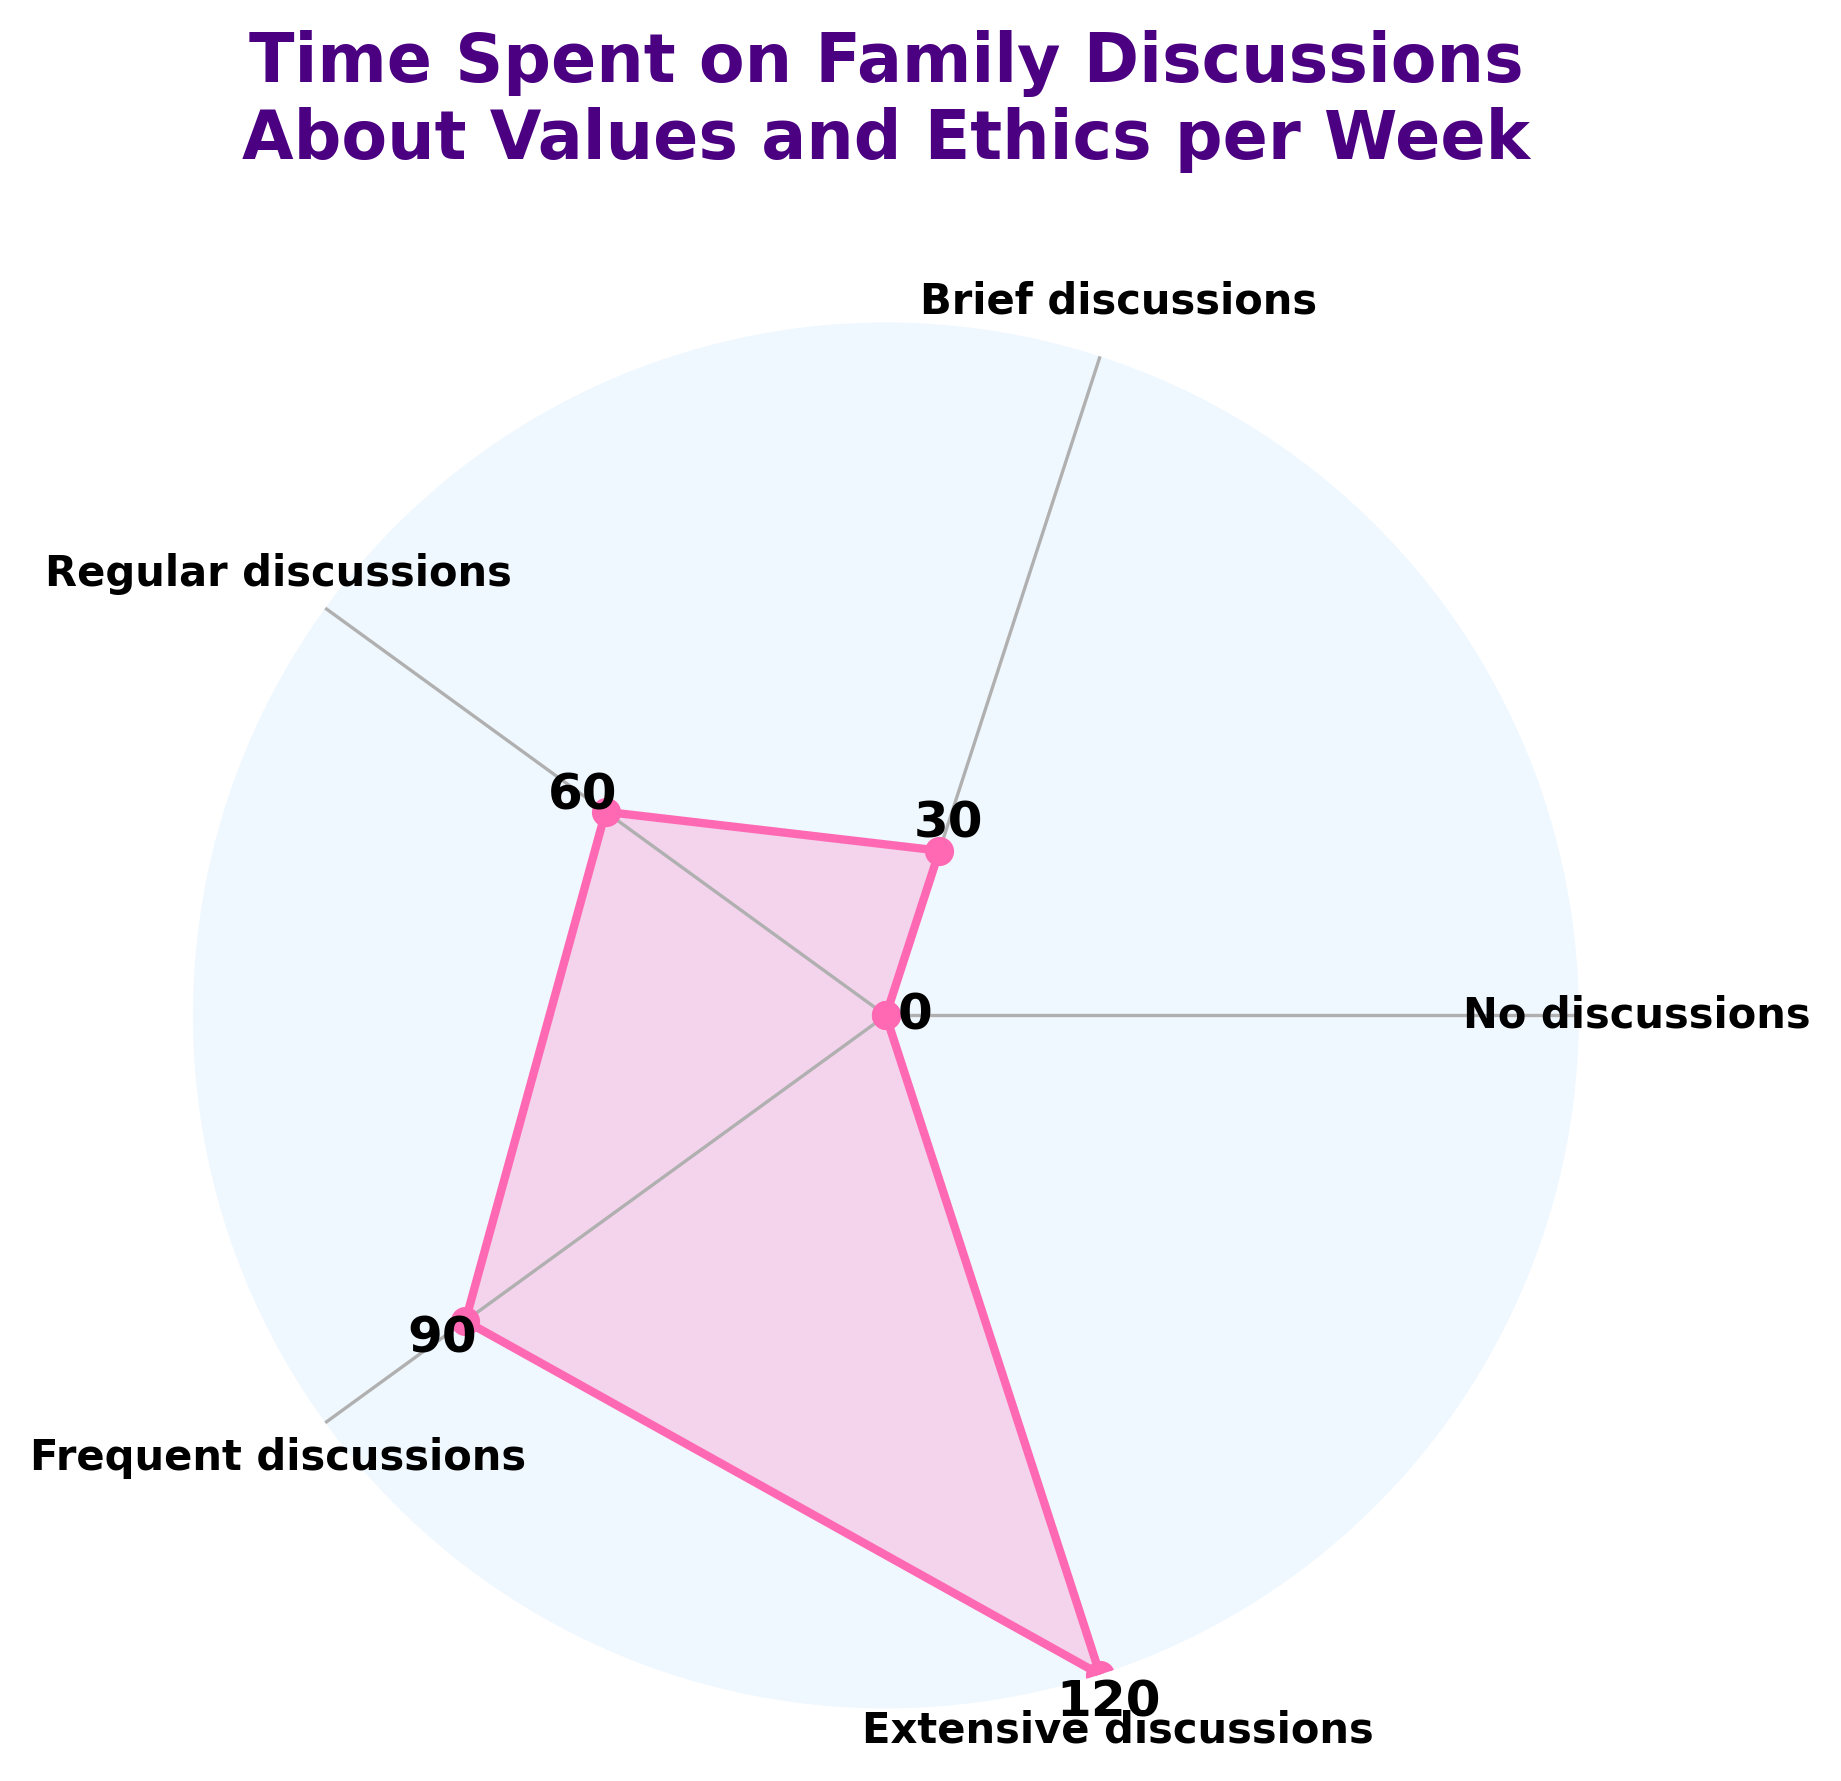What's the title of the figure? The title is displayed at the top of the figure. It reads "Time Spent on Family Discussions About Values and Ethics per Week".
Answer: Time Spent on Family Discussions About Values and Ethics per Week How many categories are displayed in the figure? The categories are labeled around the plot's perimeter. There are five labels: "No discussions", "Brief discussions", "Regular discussions", "Frequent discussions", and "Extensive discussions".
Answer: 5 Which category has the highest value? The value labels near the plot’s perimeter indicate the minutes spent on family discussions. The category "Extensive discussions" has the highest value, as shown by the label "120".
Answer: Extensive discussions What is the value of the Brief discussions category? The figure shows each category's value next to its position. The "Brief discussions" category has a value of 30 minutes.
Answer: 30 How much more time does the Regular discussions category have over the No discussions category? To find the difference, subtract the value of the No discussions category (0 minutes) from the value of the Regular discussions category (60 minutes).
Answer: 60 What is the average time spent on family discussions (considering all categories)? The sum of values (0 + 30 + 60 + 90 + 120) is 300 minutes. There are 5 categories, so the average is 300 / 5 = 60 minutes.
Answer: 60 How does the time spent on Frequent discussions compare with the time spent on Regular discussions? The value for Frequent discussions (90 minutes) is greater than that for Regular discussions (60 minutes). The difference is 90 - 60 = 30 minutes.
Answer: 30 What segment of the plot has the lowest value, and what is this value? The segment labeled "No discussions" has the lowest value, indicated by a value of 0 minutes on the plot.
Answer: No discussions; 0 What is the median value of the time categories? Arranging the values (0, 30, 60, 90, 120) in ascending order, the median is the middle value, which is 60 minutes.
Answer: 60 